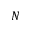<formula> <loc_0><loc_0><loc_500><loc_500>N</formula> 